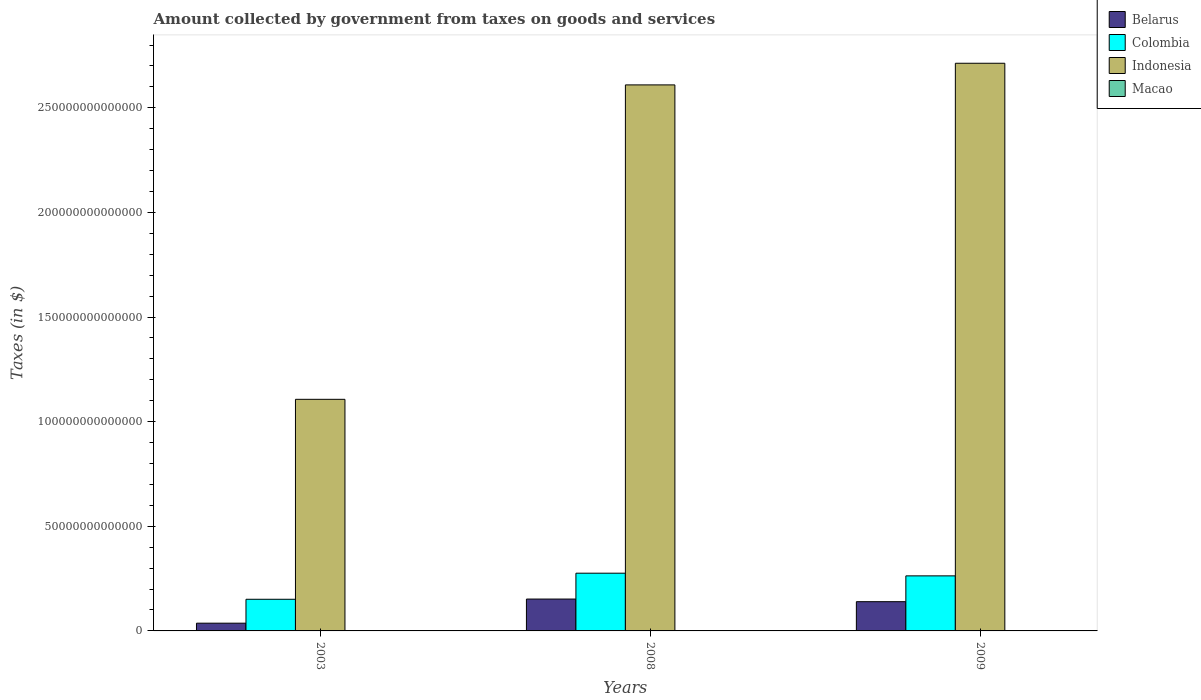How many bars are there on the 1st tick from the right?
Provide a succinct answer. 4. What is the label of the 1st group of bars from the left?
Your answer should be compact. 2003. In how many cases, is the number of bars for a given year not equal to the number of legend labels?
Offer a terse response. 0. What is the amount collected by government from taxes on goods and services in Macao in 2009?
Your answer should be very brief. 4.67e+1. Across all years, what is the maximum amount collected by government from taxes on goods and services in Belarus?
Make the answer very short. 1.52e+13. Across all years, what is the minimum amount collected by government from taxes on goods and services in Macao?
Offer a very short reply. 1.17e+1. In which year was the amount collected by government from taxes on goods and services in Macao maximum?
Provide a short and direct response. 2008. What is the total amount collected by government from taxes on goods and services in Indonesia in the graph?
Your answer should be compact. 6.43e+14. What is the difference between the amount collected by government from taxes on goods and services in Indonesia in 2003 and that in 2008?
Provide a short and direct response. -1.50e+14. What is the difference between the amount collected by government from taxes on goods and services in Belarus in 2008 and the amount collected by government from taxes on goods and services in Indonesia in 2009?
Keep it short and to the point. -2.56e+14. What is the average amount collected by government from taxes on goods and services in Indonesia per year?
Provide a short and direct response. 2.14e+14. In the year 2008, what is the difference between the amount collected by government from taxes on goods and services in Colombia and amount collected by government from taxes on goods and services in Macao?
Make the answer very short. 2.75e+13. What is the ratio of the amount collected by government from taxes on goods and services in Belarus in 2003 to that in 2009?
Your answer should be very brief. 0.26. Is the difference between the amount collected by government from taxes on goods and services in Colombia in 2008 and 2009 greater than the difference between the amount collected by government from taxes on goods and services in Macao in 2008 and 2009?
Give a very brief answer. Yes. What is the difference between the highest and the second highest amount collected by government from taxes on goods and services in Macao?
Offer a very short reply. 8.05e+07. What is the difference between the highest and the lowest amount collected by government from taxes on goods and services in Belarus?
Offer a very short reply. 1.15e+13. In how many years, is the amount collected by government from taxes on goods and services in Colombia greater than the average amount collected by government from taxes on goods and services in Colombia taken over all years?
Provide a succinct answer. 2. Is it the case that in every year, the sum of the amount collected by government from taxes on goods and services in Colombia and amount collected by government from taxes on goods and services in Indonesia is greater than the sum of amount collected by government from taxes on goods and services in Macao and amount collected by government from taxes on goods and services in Belarus?
Your response must be concise. Yes. Are all the bars in the graph horizontal?
Make the answer very short. No. What is the difference between two consecutive major ticks on the Y-axis?
Provide a short and direct response. 5.00e+13. Does the graph contain grids?
Make the answer very short. No. How many legend labels are there?
Your response must be concise. 4. What is the title of the graph?
Give a very brief answer. Amount collected by government from taxes on goods and services. Does "South Asia" appear as one of the legend labels in the graph?
Your answer should be compact. No. What is the label or title of the Y-axis?
Keep it short and to the point. Taxes (in $). What is the Taxes (in $) of Belarus in 2003?
Provide a short and direct response. 3.70e+12. What is the Taxes (in $) of Colombia in 2003?
Your answer should be very brief. 1.51e+13. What is the Taxes (in $) of Indonesia in 2003?
Give a very brief answer. 1.11e+14. What is the Taxes (in $) of Macao in 2003?
Offer a very short reply. 1.17e+1. What is the Taxes (in $) of Belarus in 2008?
Offer a terse response. 1.52e+13. What is the Taxes (in $) in Colombia in 2008?
Make the answer very short. 2.76e+13. What is the Taxes (in $) of Indonesia in 2008?
Offer a very short reply. 2.61e+14. What is the Taxes (in $) in Macao in 2008?
Your answer should be very brief. 4.68e+1. What is the Taxes (in $) in Belarus in 2009?
Provide a short and direct response. 1.40e+13. What is the Taxes (in $) in Colombia in 2009?
Offer a very short reply. 2.63e+13. What is the Taxes (in $) in Indonesia in 2009?
Offer a terse response. 2.71e+14. What is the Taxes (in $) of Macao in 2009?
Your answer should be very brief. 4.67e+1. Across all years, what is the maximum Taxes (in $) in Belarus?
Give a very brief answer. 1.52e+13. Across all years, what is the maximum Taxes (in $) in Colombia?
Your answer should be compact. 2.76e+13. Across all years, what is the maximum Taxes (in $) in Indonesia?
Provide a short and direct response. 2.71e+14. Across all years, what is the maximum Taxes (in $) of Macao?
Ensure brevity in your answer.  4.68e+1. Across all years, what is the minimum Taxes (in $) of Belarus?
Keep it short and to the point. 3.70e+12. Across all years, what is the minimum Taxes (in $) of Colombia?
Make the answer very short. 1.51e+13. Across all years, what is the minimum Taxes (in $) of Indonesia?
Give a very brief answer. 1.11e+14. Across all years, what is the minimum Taxes (in $) in Macao?
Provide a short and direct response. 1.17e+1. What is the total Taxes (in $) in Belarus in the graph?
Offer a terse response. 3.29e+13. What is the total Taxes (in $) of Colombia in the graph?
Provide a succinct answer. 6.90e+13. What is the total Taxes (in $) of Indonesia in the graph?
Offer a very short reply. 6.43e+14. What is the total Taxes (in $) in Macao in the graph?
Ensure brevity in your answer.  1.05e+11. What is the difference between the Taxes (in $) of Belarus in 2003 and that in 2008?
Provide a succinct answer. -1.15e+13. What is the difference between the Taxes (in $) of Colombia in 2003 and that in 2008?
Give a very brief answer. -1.25e+13. What is the difference between the Taxes (in $) in Indonesia in 2003 and that in 2008?
Provide a short and direct response. -1.50e+14. What is the difference between the Taxes (in $) in Macao in 2003 and that in 2008?
Your response must be concise. -3.51e+1. What is the difference between the Taxes (in $) of Belarus in 2003 and that in 2009?
Offer a very short reply. -1.03e+13. What is the difference between the Taxes (in $) of Colombia in 2003 and that in 2009?
Give a very brief answer. -1.12e+13. What is the difference between the Taxes (in $) of Indonesia in 2003 and that in 2009?
Offer a very short reply. -1.61e+14. What is the difference between the Taxes (in $) in Macao in 2003 and that in 2009?
Offer a very short reply. -3.50e+1. What is the difference between the Taxes (in $) in Belarus in 2008 and that in 2009?
Make the answer very short. 1.26e+12. What is the difference between the Taxes (in $) in Colombia in 2008 and that in 2009?
Provide a succinct answer. 1.28e+12. What is the difference between the Taxes (in $) of Indonesia in 2008 and that in 2009?
Provide a short and direct response. -1.03e+13. What is the difference between the Taxes (in $) of Macao in 2008 and that in 2009?
Provide a short and direct response. 8.05e+07. What is the difference between the Taxes (in $) of Belarus in 2003 and the Taxes (in $) of Colombia in 2008?
Ensure brevity in your answer.  -2.39e+13. What is the difference between the Taxes (in $) of Belarus in 2003 and the Taxes (in $) of Indonesia in 2008?
Your answer should be compact. -2.57e+14. What is the difference between the Taxes (in $) in Belarus in 2003 and the Taxes (in $) in Macao in 2008?
Your answer should be compact. 3.66e+12. What is the difference between the Taxes (in $) in Colombia in 2003 and the Taxes (in $) in Indonesia in 2008?
Offer a very short reply. -2.46e+14. What is the difference between the Taxes (in $) in Colombia in 2003 and the Taxes (in $) in Macao in 2008?
Your answer should be compact. 1.51e+13. What is the difference between the Taxes (in $) of Indonesia in 2003 and the Taxes (in $) of Macao in 2008?
Provide a succinct answer. 1.11e+14. What is the difference between the Taxes (in $) of Belarus in 2003 and the Taxes (in $) of Colombia in 2009?
Your answer should be compact. -2.26e+13. What is the difference between the Taxes (in $) of Belarus in 2003 and the Taxes (in $) of Indonesia in 2009?
Your answer should be very brief. -2.68e+14. What is the difference between the Taxes (in $) of Belarus in 2003 and the Taxes (in $) of Macao in 2009?
Give a very brief answer. 3.66e+12. What is the difference between the Taxes (in $) of Colombia in 2003 and the Taxes (in $) of Indonesia in 2009?
Provide a succinct answer. -2.56e+14. What is the difference between the Taxes (in $) of Colombia in 2003 and the Taxes (in $) of Macao in 2009?
Your response must be concise. 1.51e+13. What is the difference between the Taxes (in $) of Indonesia in 2003 and the Taxes (in $) of Macao in 2009?
Your answer should be compact. 1.11e+14. What is the difference between the Taxes (in $) of Belarus in 2008 and the Taxes (in $) of Colombia in 2009?
Make the answer very short. -1.11e+13. What is the difference between the Taxes (in $) in Belarus in 2008 and the Taxes (in $) in Indonesia in 2009?
Your answer should be very brief. -2.56e+14. What is the difference between the Taxes (in $) of Belarus in 2008 and the Taxes (in $) of Macao in 2009?
Keep it short and to the point. 1.52e+13. What is the difference between the Taxes (in $) of Colombia in 2008 and the Taxes (in $) of Indonesia in 2009?
Your response must be concise. -2.44e+14. What is the difference between the Taxes (in $) of Colombia in 2008 and the Taxes (in $) of Macao in 2009?
Give a very brief answer. 2.75e+13. What is the difference between the Taxes (in $) in Indonesia in 2008 and the Taxes (in $) in Macao in 2009?
Make the answer very short. 2.61e+14. What is the average Taxes (in $) of Belarus per year?
Keep it short and to the point. 1.10e+13. What is the average Taxes (in $) of Colombia per year?
Offer a terse response. 2.30e+13. What is the average Taxes (in $) in Indonesia per year?
Your answer should be compact. 2.14e+14. What is the average Taxes (in $) in Macao per year?
Offer a terse response. 3.51e+1. In the year 2003, what is the difference between the Taxes (in $) in Belarus and Taxes (in $) in Colombia?
Provide a succinct answer. -1.14e+13. In the year 2003, what is the difference between the Taxes (in $) in Belarus and Taxes (in $) in Indonesia?
Your response must be concise. -1.07e+14. In the year 2003, what is the difference between the Taxes (in $) of Belarus and Taxes (in $) of Macao?
Ensure brevity in your answer.  3.69e+12. In the year 2003, what is the difference between the Taxes (in $) of Colombia and Taxes (in $) of Indonesia?
Your answer should be very brief. -9.56e+13. In the year 2003, what is the difference between the Taxes (in $) in Colombia and Taxes (in $) in Macao?
Your response must be concise. 1.51e+13. In the year 2003, what is the difference between the Taxes (in $) of Indonesia and Taxes (in $) of Macao?
Offer a terse response. 1.11e+14. In the year 2008, what is the difference between the Taxes (in $) of Belarus and Taxes (in $) of Colombia?
Offer a terse response. -1.24e+13. In the year 2008, what is the difference between the Taxes (in $) in Belarus and Taxes (in $) in Indonesia?
Provide a succinct answer. -2.46e+14. In the year 2008, what is the difference between the Taxes (in $) in Belarus and Taxes (in $) in Macao?
Offer a terse response. 1.52e+13. In the year 2008, what is the difference between the Taxes (in $) of Colombia and Taxes (in $) of Indonesia?
Keep it short and to the point. -2.33e+14. In the year 2008, what is the difference between the Taxes (in $) of Colombia and Taxes (in $) of Macao?
Your answer should be very brief. 2.75e+13. In the year 2008, what is the difference between the Taxes (in $) in Indonesia and Taxes (in $) in Macao?
Give a very brief answer. 2.61e+14. In the year 2009, what is the difference between the Taxes (in $) of Belarus and Taxes (in $) of Colombia?
Provide a succinct answer. -1.23e+13. In the year 2009, what is the difference between the Taxes (in $) of Belarus and Taxes (in $) of Indonesia?
Give a very brief answer. -2.57e+14. In the year 2009, what is the difference between the Taxes (in $) of Belarus and Taxes (in $) of Macao?
Keep it short and to the point. 1.39e+13. In the year 2009, what is the difference between the Taxes (in $) in Colombia and Taxes (in $) in Indonesia?
Ensure brevity in your answer.  -2.45e+14. In the year 2009, what is the difference between the Taxes (in $) of Colombia and Taxes (in $) of Macao?
Your answer should be very brief. 2.63e+13. In the year 2009, what is the difference between the Taxes (in $) of Indonesia and Taxes (in $) of Macao?
Your answer should be very brief. 2.71e+14. What is the ratio of the Taxes (in $) of Belarus in 2003 to that in 2008?
Your answer should be compact. 0.24. What is the ratio of the Taxes (in $) of Colombia in 2003 to that in 2008?
Make the answer very short. 0.55. What is the ratio of the Taxes (in $) of Indonesia in 2003 to that in 2008?
Offer a terse response. 0.42. What is the ratio of the Taxes (in $) in Macao in 2003 to that in 2008?
Make the answer very short. 0.25. What is the ratio of the Taxes (in $) in Belarus in 2003 to that in 2009?
Offer a terse response. 0.27. What is the ratio of the Taxes (in $) of Colombia in 2003 to that in 2009?
Ensure brevity in your answer.  0.57. What is the ratio of the Taxes (in $) in Indonesia in 2003 to that in 2009?
Offer a terse response. 0.41. What is the ratio of the Taxes (in $) in Macao in 2003 to that in 2009?
Offer a very short reply. 0.25. What is the ratio of the Taxes (in $) of Belarus in 2008 to that in 2009?
Give a very brief answer. 1.09. What is the ratio of the Taxes (in $) in Colombia in 2008 to that in 2009?
Provide a short and direct response. 1.05. What is the ratio of the Taxes (in $) in Indonesia in 2008 to that in 2009?
Make the answer very short. 0.96. What is the difference between the highest and the second highest Taxes (in $) in Belarus?
Offer a terse response. 1.26e+12. What is the difference between the highest and the second highest Taxes (in $) of Colombia?
Your answer should be compact. 1.28e+12. What is the difference between the highest and the second highest Taxes (in $) in Indonesia?
Your answer should be very brief. 1.03e+13. What is the difference between the highest and the second highest Taxes (in $) of Macao?
Provide a short and direct response. 8.05e+07. What is the difference between the highest and the lowest Taxes (in $) of Belarus?
Ensure brevity in your answer.  1.15e+13. What is the difference between the highest and the lowest Taxes (in $) of Colombia?
Your answer should be very brief. 1.25e+13. What is the difference between the highest and the lowest Taxes (in $) of Indonesia?
Keep it short and to the point. 1.61e+14. What is the difference between the highest and the lowest Taxes (in $) of Macao?
Keep it short and to the point. 3.51e+1. 